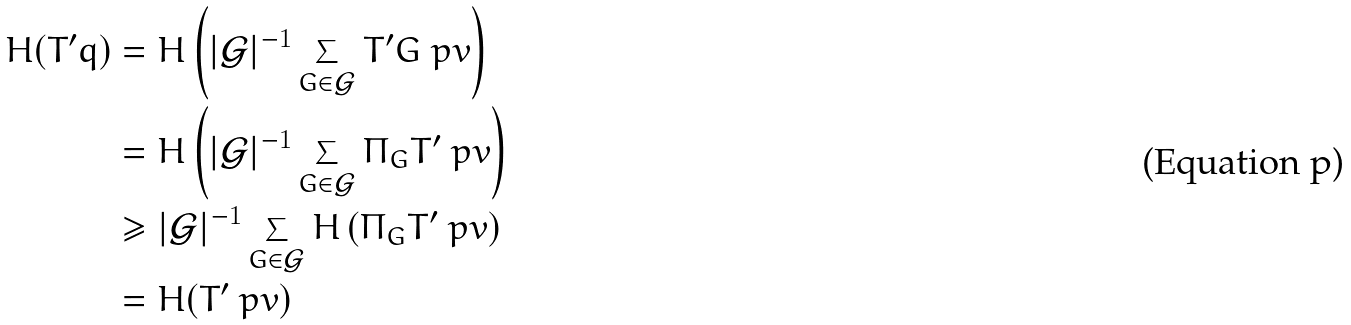Convert formula to latex. <formula><loc_0><loc_0><loc_500><loc_500>H ( T ^ { \prime } q ) & = H \left ( | \mathcal { G } | ^ { - 1 } \sum _ { G \in \mathcal { G } } T ^ { \prime } G \ p v \right ) \\ & = H \left ( | \mathcal { G } | ^ { - 1 } \sum _ { G \in \mathcal { G } } \Pi _ { G } T ^ { \prime } \ p v \right ) \\ & \geq | \mathcal { G } | ^ { - 1 } \sum _ { G \in \mathcal { G } } H \left ( \Pi _ { G } T ^ { \prime } \ p v \right ) \\ & = H ( T ^ { \prime } \ p v )</formula> 